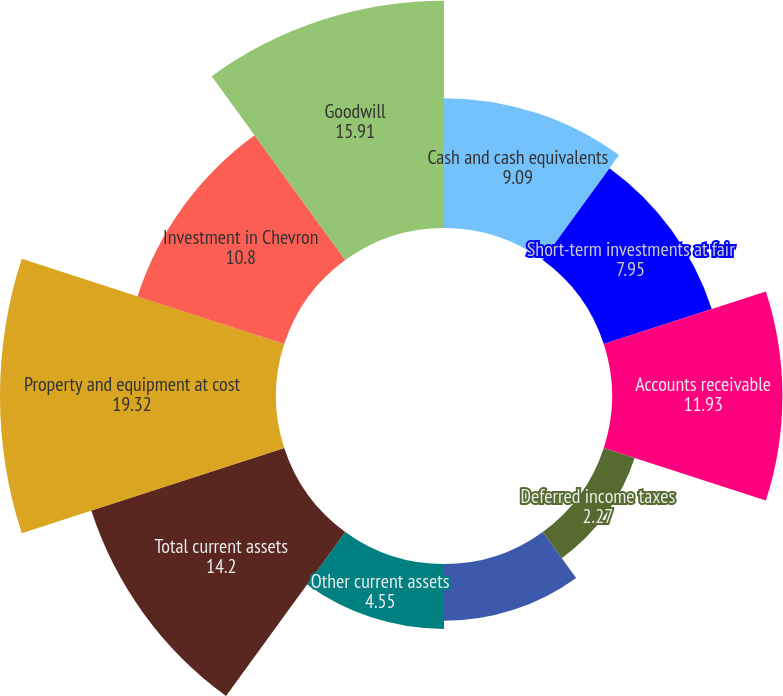Convert chart. <chart><loc_0><loc_0><loc_500><loc_500><pie_chart><fcel>Cash and cash equivalents<fcel>Short-term investments at fair<fcel>Accounts receivable<fcel>Deferred income taxes<fcel>Current assets held for sale<fcel>Other current assets<fcel>Total current assets<fcel>Property and equipment at cost<fcel>Investment in Chevron<fcel>Goodwill<nl><fcel>9.09%<fcel>7.95%<fcel>11.93%<fcel>2.27%<fcel>3.98%<fcel>4.55%<fcel>14.2%<fcel>19.32%<fcel>10.8%<fcel>15.91%<nl></chart> 